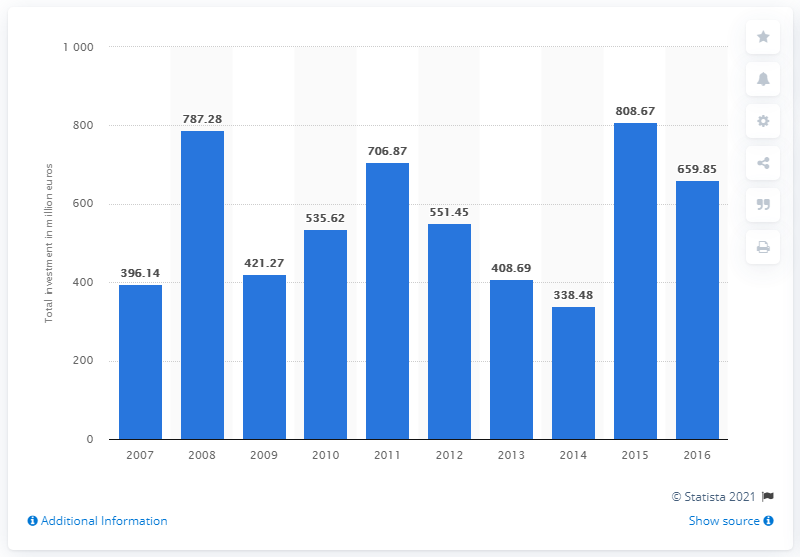Indicate a few pertinent items in this graphic. In 2016, the value of private equity investments in Poland was 659.85. In 2015, the total value of private equity investments was 808.67... 